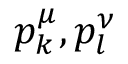Convert formula to latex. <formula><loc_0><loc_0><loc_500><loc_500>p _ { k } ^ { \mu } , p _ { l } ^ { \nu }</formula> 